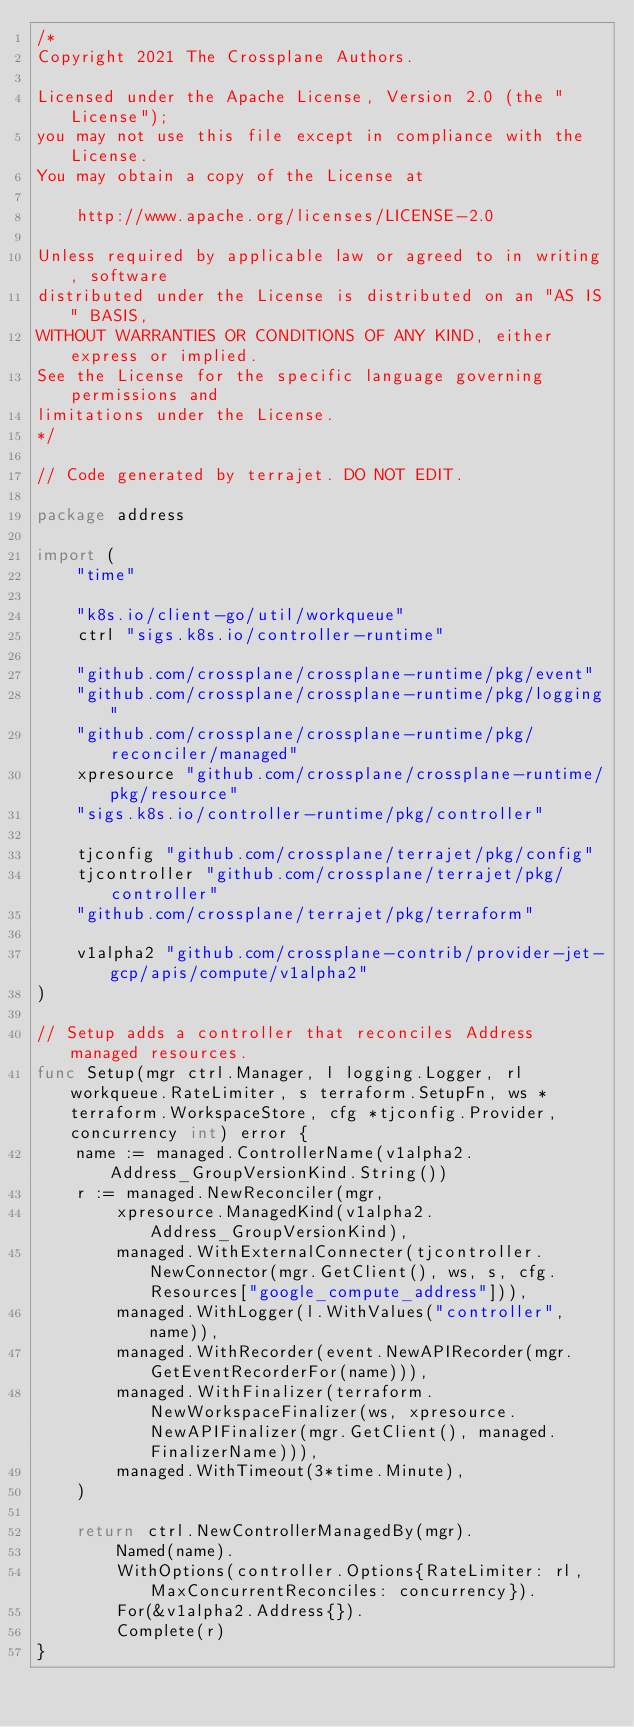<code> <loc_0><loc_0><loc_500><loc_500><_Go_>/*
Copyright 2021 The Crossplane Authors.

Licensed under the Apache License, Version 2.0 (the "License");
you may not use this file except in compliance with the License.
You may obtain a copy of the License at

    http://www.apache.org/licenses/LICENSE-2.0

Unless required by applicable law or agreed to in writing, software
distributed under the License is distributed on an "AS IS" BASIS,
WITHOUT WARRANTIES OR CONDITIONS OF ANY KIND, either express or implied.
See the License for the specific language governing permissions and
limitations under the License.
*/

// Code generated by terrajet. DO NOT EDIT.

package address

import (
	"time"

	"k8s.io/client-go/util/workqueue"
	ctrl "sigs.k8s.io/controller-runtime"

	"github.com/crossplane/crossplane-runtime/pkg/event"
	"github.com/crossplane/crossplane-runtime/pkg/logging"
	"github.com/crossplane/crossplane-runtime/pkg/reconciler/managed"
	xpresource "github.com/crossplane/crossplane-runtime/pkg/resource"
	"sigs.k8s.io/controller-runtime/pkg/controller"

	tjconfig "github.com/crossplane/terrajet/pkg/config"
	tjcontroller "github.com/crossplane/terrajet/pkg/controller"
	"github.com/crossplane/terrajet/pkg/terraform"

	v1alpha2 "github.com/crossplane-contrib/provider-jet-gcp/apis/compute/v1alpha2"
)

// Setup adds a controller that reconciles Address managed resources.
func Setup(mgr ctrl.Manager, l logging.Logger, rl workqueue.RateLimiter, s terraform.SetupFn, ws *terraform.WorkspaceStore, cfg *tjconfig.Provider, concurrency int) error {
	name := managed.ControllerName(v1alpha2.Address_GroupVersionKind.String())
	r := managed.NewReconciler(mgr,
		xpresource.ManagedKind(v1alpha2.Address_GroupVersionKind),
		managed.WithExternalConnecter(tjcontroller.NewConnector(mgr.GetClient(), ws, s, cfg.Resources["google_compute_address"])),
		managed.WithLogger(l.WithValues("controller", name)),
		managed.WithRecorder(event.NewAPIRecorder(mgr.GetEventRecorderFor(name))),
		managed.WithFinalizer(terraform.NewWorkspaceFinalizer(ws, xpresource.NewAPIFinalizer(mgr.GetClient(), managed.FinalizerName))),
		managed.WithTimeout(3*time.Minute),
	)

	return ctrl.NewControllerManagedBy(mgr).
		Named(name).
		WithOptions(controller.Options{RateLimiter: rl, MaxConcurrentReconciles: concurrency}).
		For(&v1alpha2.Address{}).
		Complete(r)
}
</code> 